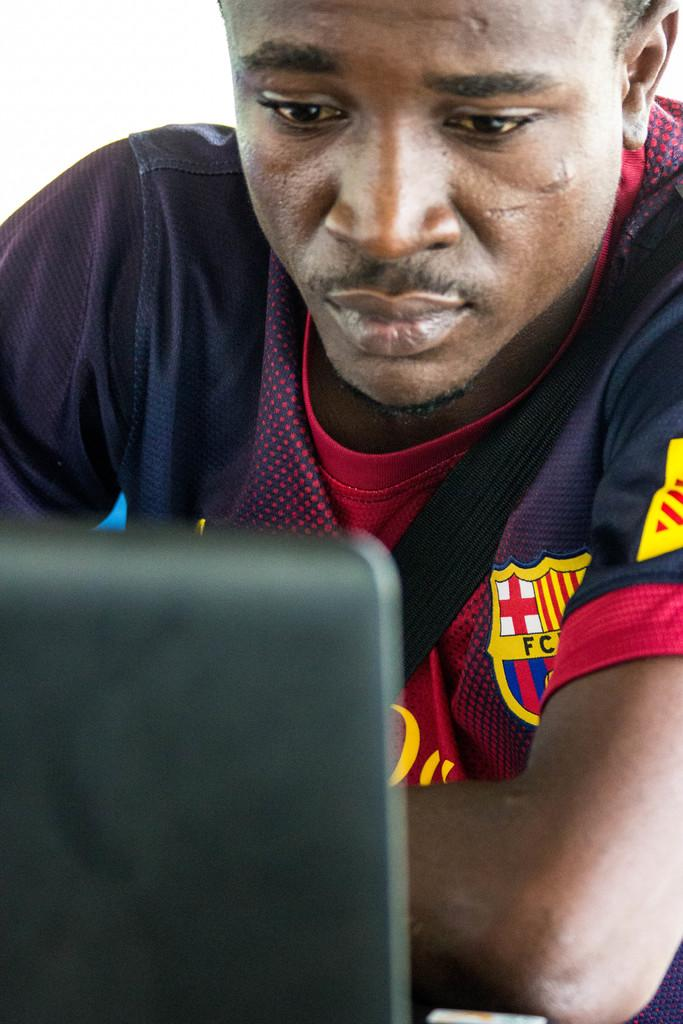<image>
Create a compact narrative representing the image presented. A man wearing a soccer shirt that has the letters FC visible. 